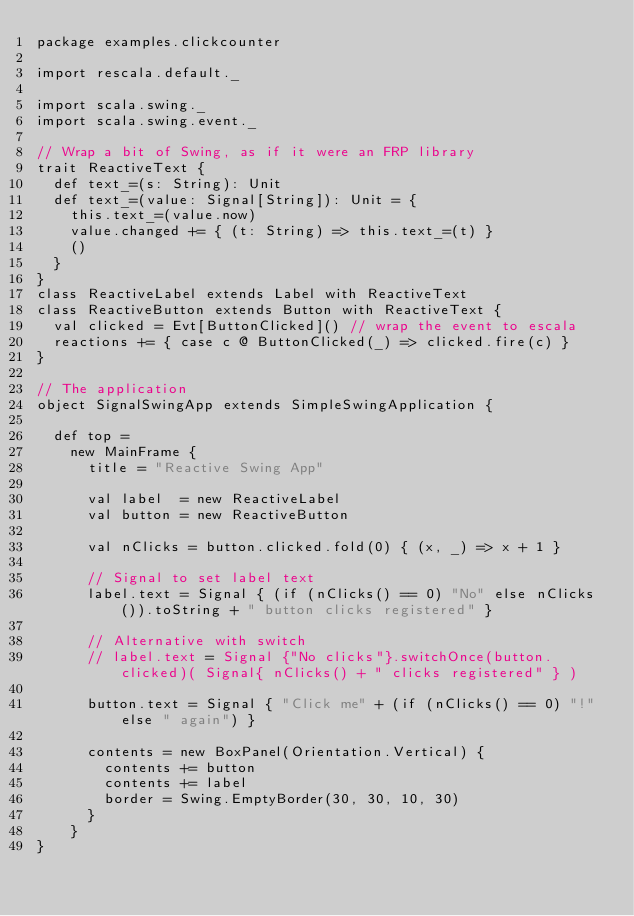<code> <loc_0><loc_0><loc_500><loc_500><_Scala_>package examples.clickcounter

import rescala.default._

import scala.swing._
import scala.swing.event._

// Wrap a bit of Swing, as if it were an FRP library
trait ReactiveText {
  def text_=(s: String): Unit
  def text_=(value: Signal[String]): Unit = {
    this.text_=(value.now)
    value.changed += { (t: String) => this.text_=(t) }
    ()
  }
}
class ReactiveLabel extends Label with ReactiveText
class ReactiveButton extends Button with ReactiveText {
  val clicked = Evt[ButtonClicked]() // wrap the event to escala
  reactions += { case c @ ButtonClicked(_) => clicked.fire(c) }
}

// The application
object SignalSwingApp extends SimpleSwingApplication {

  def top =
    new MainFrame {
      title = "Reactive Swing App"

      val label  = new ReactiveLabel
      val button = new ReactiveButton

      val nClicks = button.clicked.fold(0) { (x, _) => x + 1 }

      // Signal to set label text
      label.text = Signal { (if (nClicks() == 0) "No" else nClicks()).toString + " button clicks registered" }

      // Alternative with switch
      // label.text = Signal {"No clicks"}.switchOnce(button.clicked)( Signal{ nClicks() + " clicks registered" } )

      button.text = Signal { "Click me" + (if (nClicks() == 0) "!" else " again") }

      contents = new BoxPanel(Orientation.Vertical) {
        contents += button
        contents += label
        border = Swing.EmptyBorder(30, 30, 10, 30)
      }
    }
}
</code> 